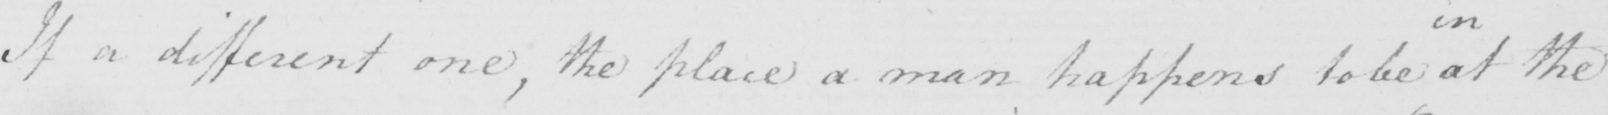Please provide the text content of this handwritten line. If a different one , the place a man happens to be at the 